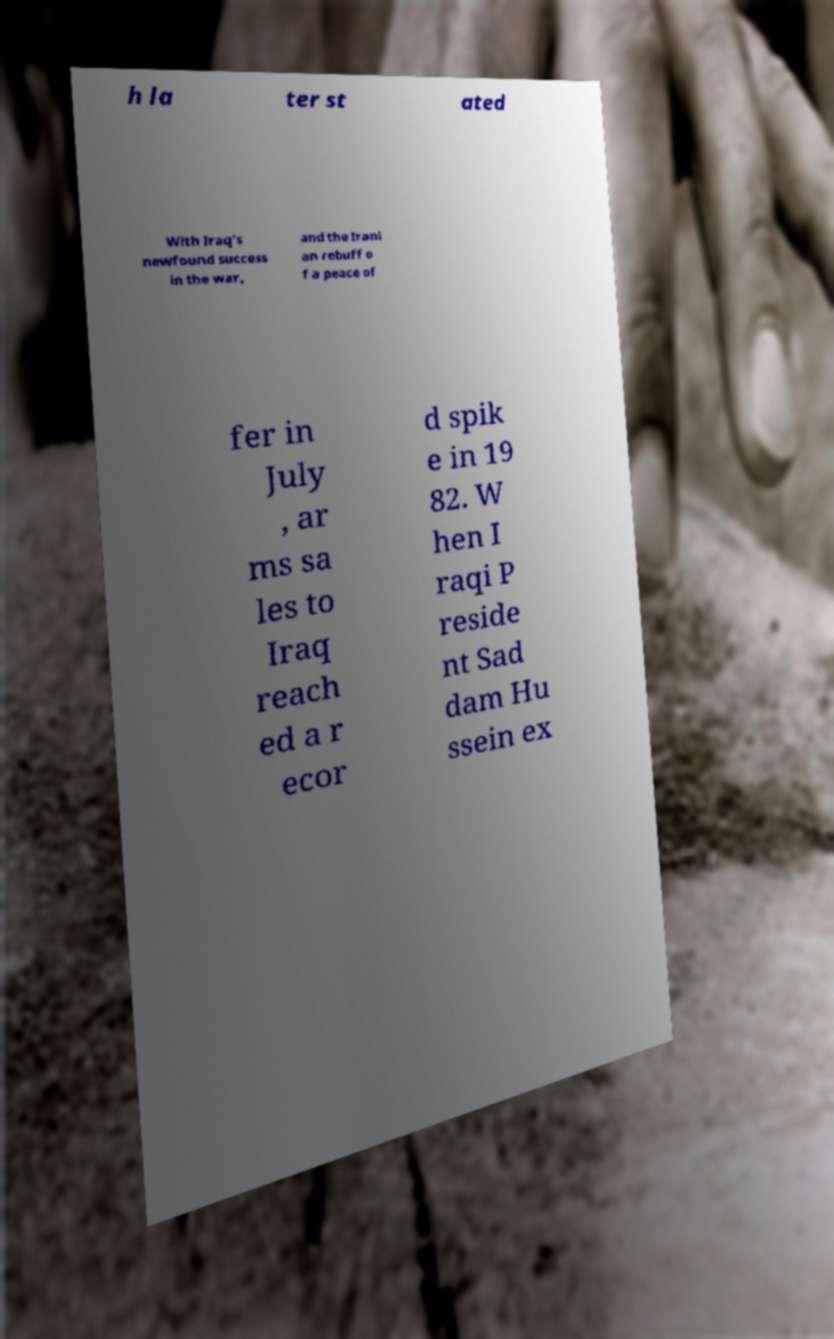Could you extract and type out the text from this image? h la ter st ated With Iraq's newfound success in the war, and the Irani an rebuff o f a peace of fer in July , ar ms sa les to Iraq reach ed a r ecor d spik e in 19 82. W hen I raqi P reside nt Sad dam Hu ssein ex 